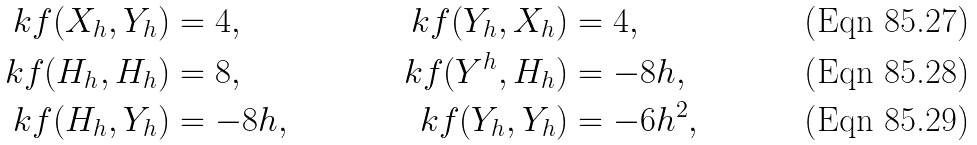<formula> <loc_0><loc_0><loc_500><loc_500>\ k f ( X _ { h } , Y _ { h } ) & = 4 , & \ k f ( Y _ { h } , X _ { h } ) & = 4 , \\ \ k f ( H _ { h } , H _ { h } ) & = 8 , & \ k f ( Y ^ { h } , H _ { h } ) & = - 8 h , \\ \ k f ( H _ { h } , Y _ { h } ) & = - 8 h , & \ k f ( Y _ { h } , Y _ { h } ) & = - 6 h ^ { 2 } ,</formula> 